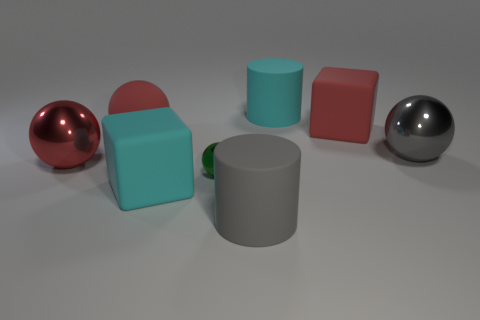Does the tiny metal thing have the same shape as the large gray metallic thing? Although the tiny object and the large gray object are both cylindrical in shape, there are distinct differences in proportions and size that set them apart. The small object appears to be a solid cylinder, while the larger one has a hollow center, resembling a cup or container. 